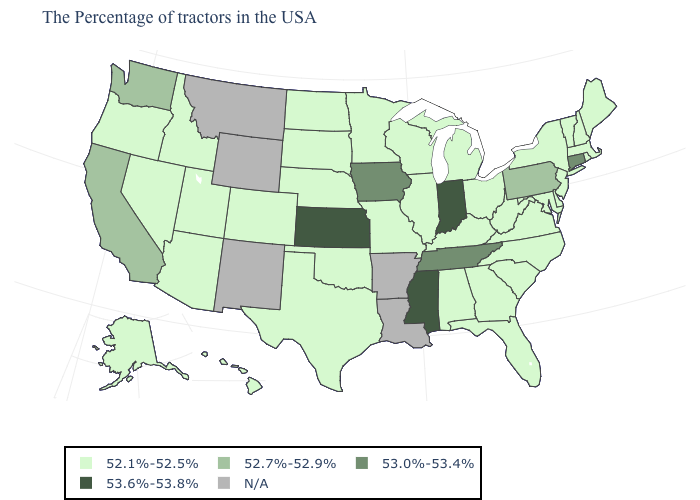What is the value of Delaware?
Give a very brief answer. 52.1%-52.5%. Is the legend a continuous bar?
Quick response, please. No. Does the first symbol in the legend represent the smallest category?
Concise answer only. Yes. How many symbols are there in the legend?
Short answer required. 5. Among the states that border Oregon , does Idaho have the highest value?
Give a very brief answer. No. Among the states that border Oregon , does Nevada have the highest value?
Be succinct. No. What is the value of Louisiana?
Short answer required. N/A. What is the lowest value in the USA?
Answer briefly. 52.1%-52.5%. What is the value of South Dakota?
Write a very short answer. 52.1%-52.5%. What is the lowest value in the Northeast?
Short answer required. 52.1%-52.5%. What is the value of Colorado?
Write a very short answer. 52.1%-52.5%. What is the value of Vermont?
Write a very short answer. 52.1%-52.5%. Does New Hampshire have the lowest value in the Northeast?
Be succinct. Yes. What is the lowest value in the Northeast?
Write a very short answer. 52.1%-52.5%. What is the highest value in states that border Delaware?
Give a very brief answer. 52.7%-52.9%. 